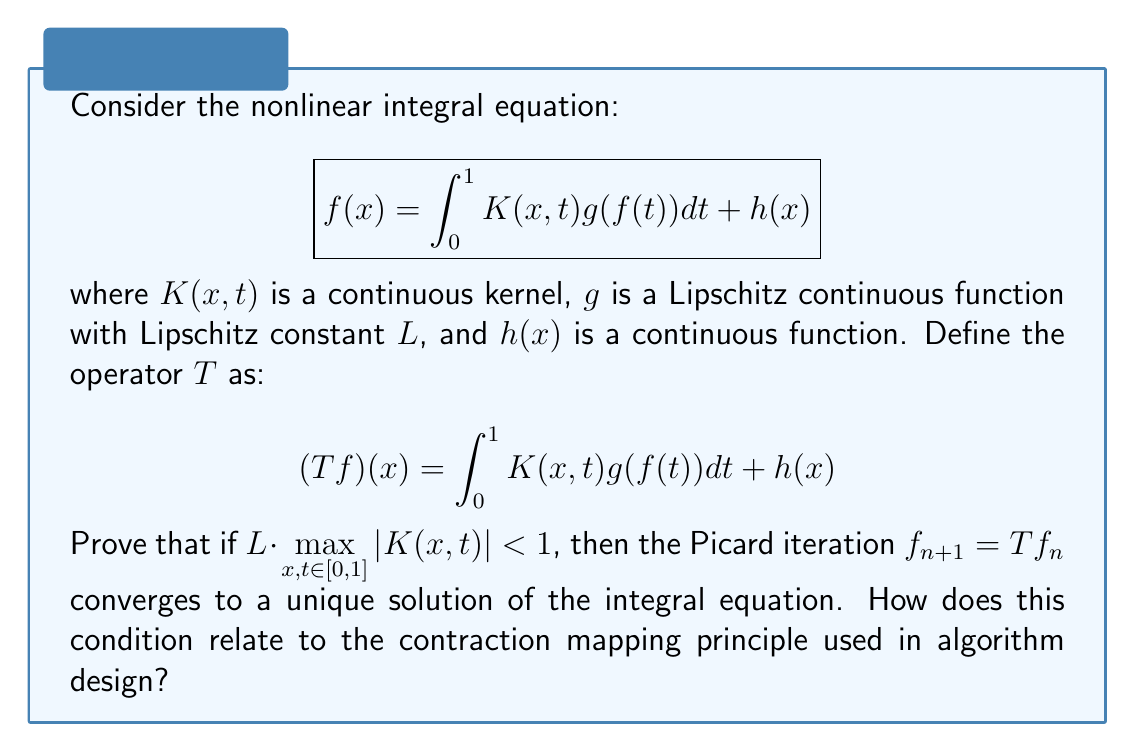Provide a solution to this math problem. To prove the convergence of the Picard iteration and relate it to algorithm design, we'll follow these steps:

1) First, we'll show that $T$ is a contraction mapping on the space of continuous functions $C[0,1]$ with the supremum norm.

2) For any two functions $f, \phi \in C[0,1]$:

   $$\begin{align}
   |(Tf)(x) - (T\phi)(x)| &= \left|\int_0^1 K(x,t)[g(f(t)) - g(\phi(t))]dt\right| \\
   &\leq \int_0^1 |K(x,t)| |g(f(t)) - g(\phi(t))|dt
   \end{align}$$

3) Using the Lipschitz condition on $g$:

   $$\begin{align}
   |(Tf)(x) - (T\phi)(x)| &\leq \int_0^1 |K(x,t)| L|f(t) - \phi(t)|dt \\
   &\leq L \cdot \max_{x,t \in [0,1]} |K(x,t)| \int_0^1 |f(t) - \phi(t)|dt \\
   &\leq L \cdot \max_{x,t \in [0,1]} |K(x,t)| \cdot \|f - \phi\|_\infty
   \end{align}$$

4) Let $q = L \cdot \max_{x,t \in [0,1]} |K(x,t)|$. Given that $q < 1$:

   $$\|Tf - T\phi\|_\infty \leq q \cdot \|f - \phi\|_\infty$$

5) This proves that $T$ is a contraction mapping with contraction constant $q < 1$.

6) By the Banach Fixed Point Theorem (Contraction Mapping Principle), $T$ has a unique fixed point $f^*$, and the sequence defined by $f_{n+1} = Tf_n$ converges to $f^*$ for any initial $f_0 \in C[0,1]$.

7) This fixed point $f^*$ is the unique solution to our integral equation.

Relation to algorithm design:
The contraction mapping principle is fundamental in many iterative algorithms, including:
- Newton's method for root-finding
- Value iteration in reinforcement learning
- Fixed-point iteration in numerical analysis

The condition $q < 1$ ensures that each iteration brings us closer to the solution, with the error decreasing by at least a factor of $q$ each time. This guarantees convergence and provides a bound on the rate of convergence, which is crucial for algorithm analysis and design.
Answer: The Picard iteration converges if $L \cdot \max_{x,t \in [0,1]} |K(x,t)| < 1$, where $L$ is the Lipschitz constant of $g$. This condition ensures the operator is a contraction mapping, relating to the contraction mapping principle used in iterative algorithm design and analysis. 